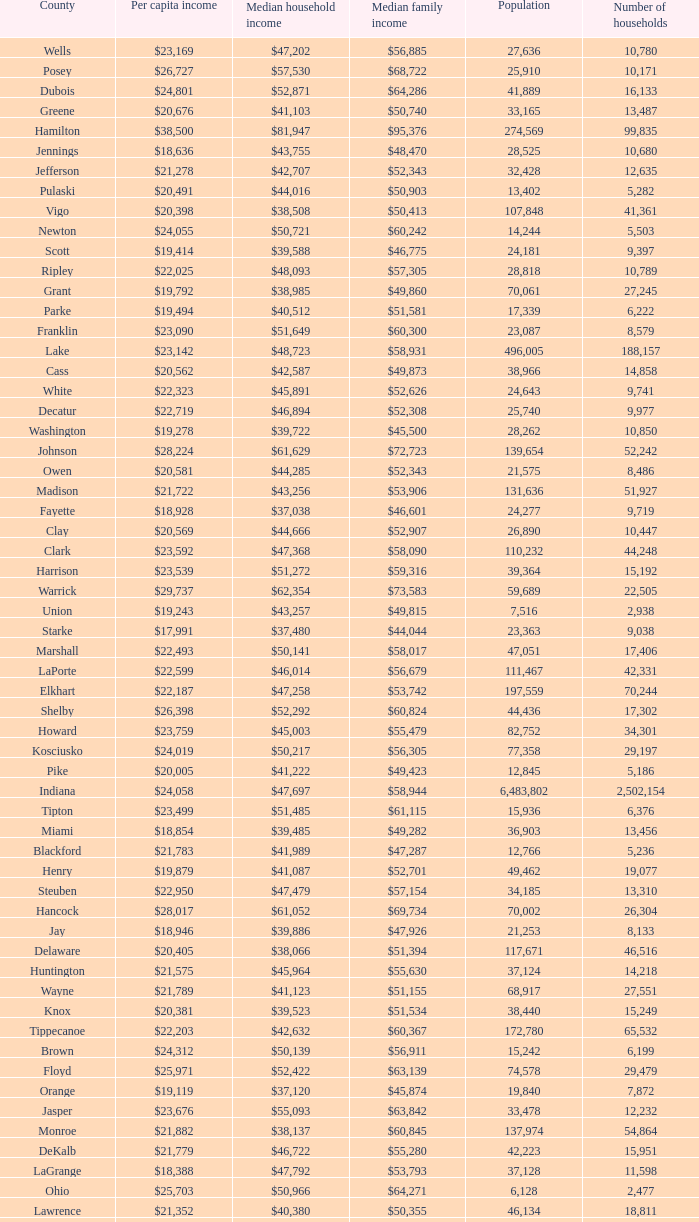What County has a Median household income of $46,872? Gibson. 